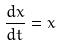<formula> <loc_0><loc_0><loc_500><loc_500>\frac { d x } { d t } = x</formula> 